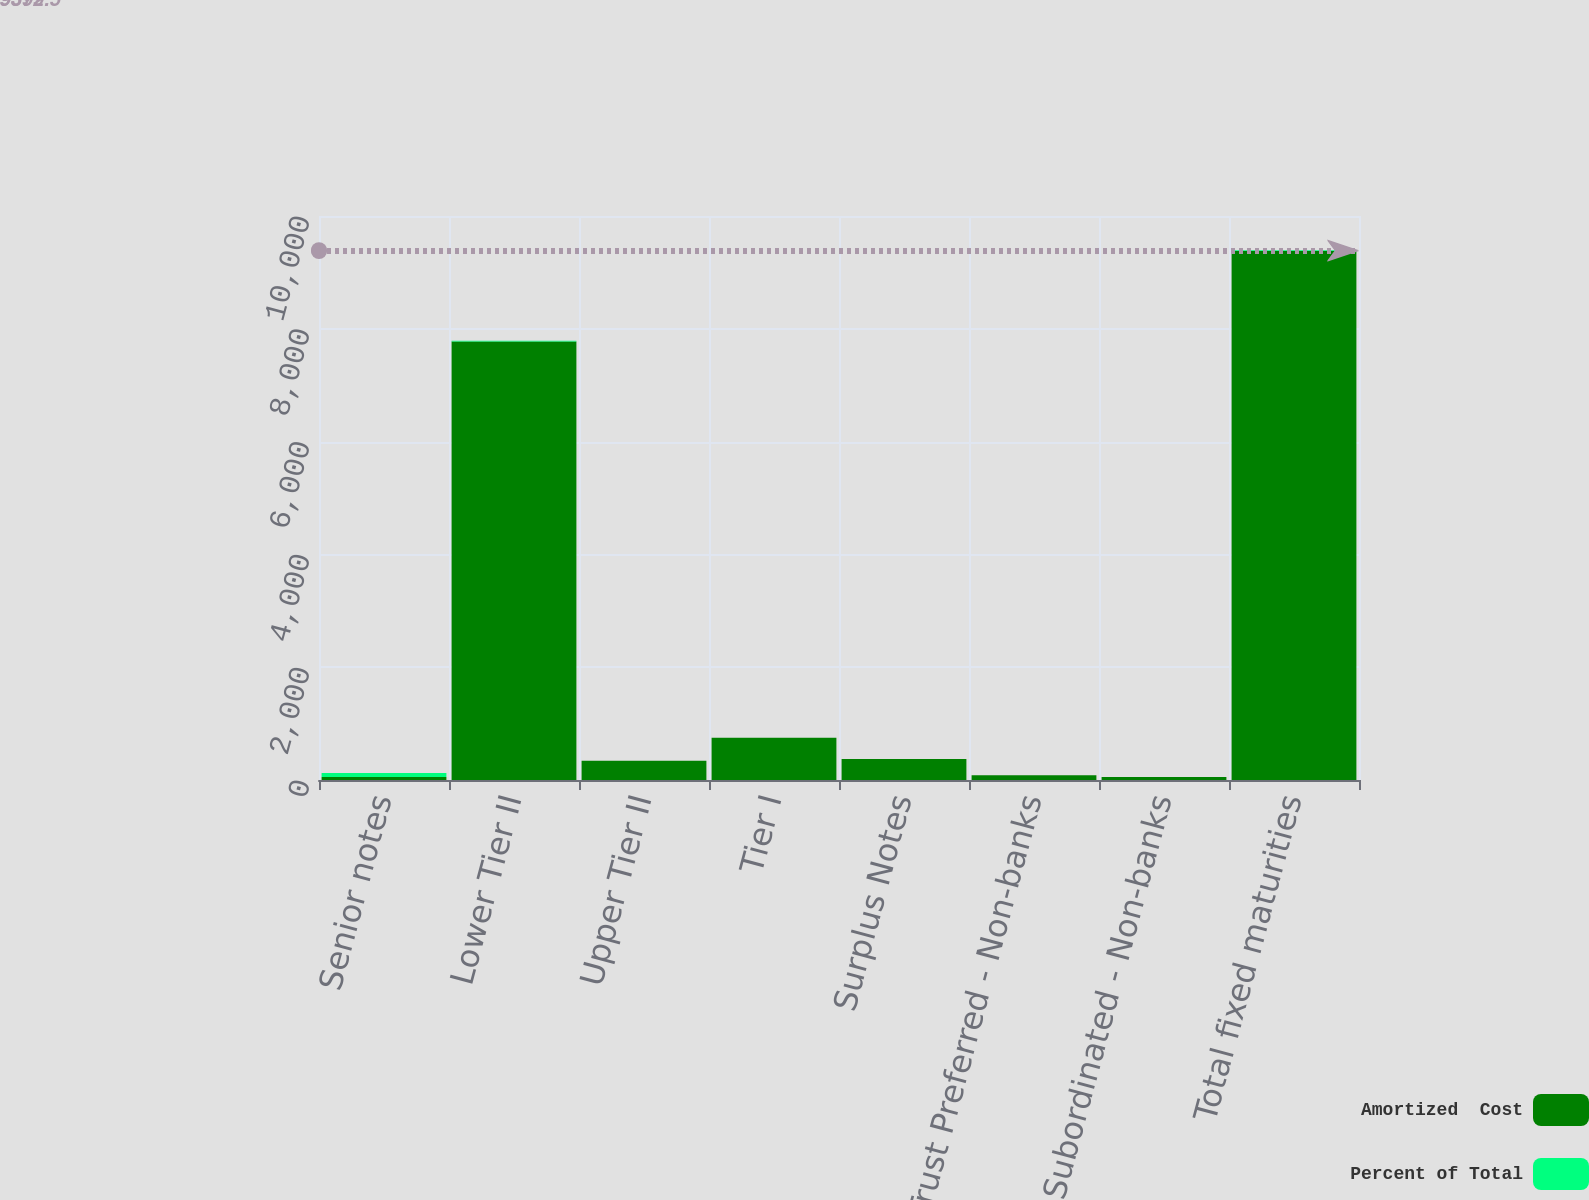<chart> <loc_0><loc_0><loc_500><loc_500><stacked_bar_chart><ecel><fcel>Senior notes<fcel>Lower Tier II<fcel>Upper Tier II<fcel>Tier I<fcel>Surplus Notes<fcel>Trust Preferred - Non-banks<fcel>Other Subordinated - Non-banks<fcel>Total fixed maturities<nl><fcel>Amortized  Cost<fcel>52<fcel>7777<fcel>340<fcel>750<fcel>374<fcel>86<fcel>52<fcel>9379<nl><fcel>Percent of Total<fcel>73.5<fcel>11.2<fcel>0.5<fcel>1.1<fcel>0.5<fcel>0.1<fcel>0.1<fcel>13.5<nl></chart> 